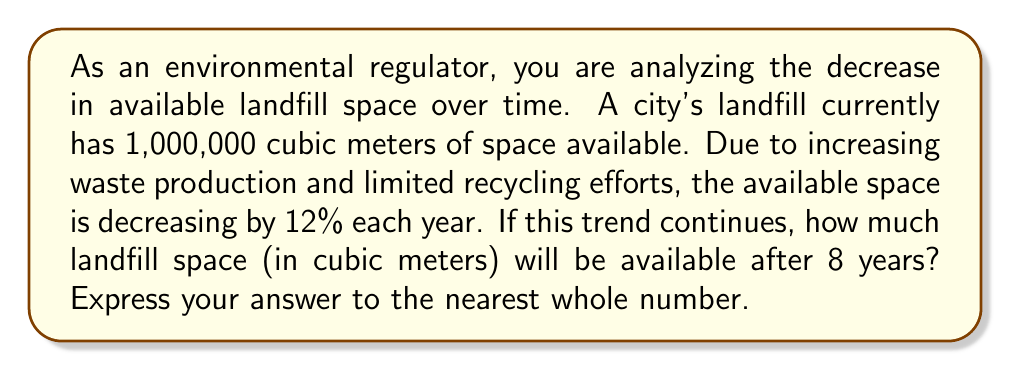Show me your answer to this math problem. To solve this problem, we need to use the exponential decay formula:

$$A(t) = A_0 \cdot (1-r)^t$$

Where:
$A(t)$ = Amount after time $t$
$A_0$ = Initial amount
$r$ = Rate of decay (as a decimal)
$t$ = Time (in years)

Given:
$A_0 = 1,000,000$ cubic meters
$r = 12\% = 0.12$
$t = 8$ years

Let's plug these values into the formula:

$$A(8) = 1,000,000 \cdot (1-0.12)^8$$

$$A(8) = 1,000,000 \cdot (0.88)^8$$

Now, let's calculate $(0.88)^8$:

$$(0.88)^8 \approx 0.3666$$

Multiplying this by the initial amount:

$$A(8) = 1,000,000 \cdot 0.3666 \approx 366,600$$

Rounding to the nearest whole number:

$$A(8) \approx 366,600 \text{ cubic meters}$$
Answer: 366,600 cubic meters 